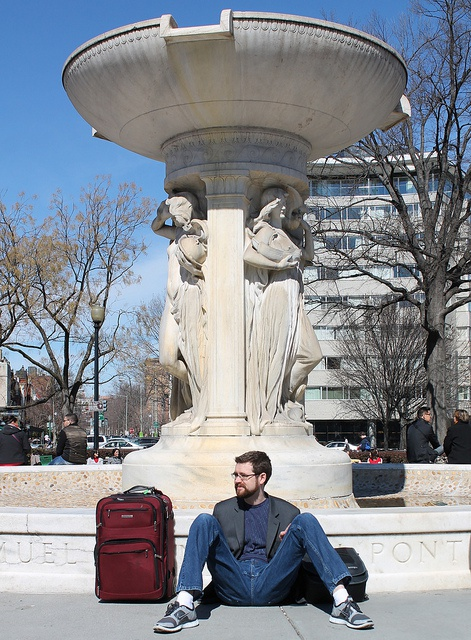Describe the objects in this image and their specific colors. I can see people in gray, black, darkblue, and navy tones, suitcase in gray, maroon, black, and brown tones, people in gray, black, and darkgray tones, people in gray, black, and darkgray tones, and people in gray, black, and maroon tones in this image. 